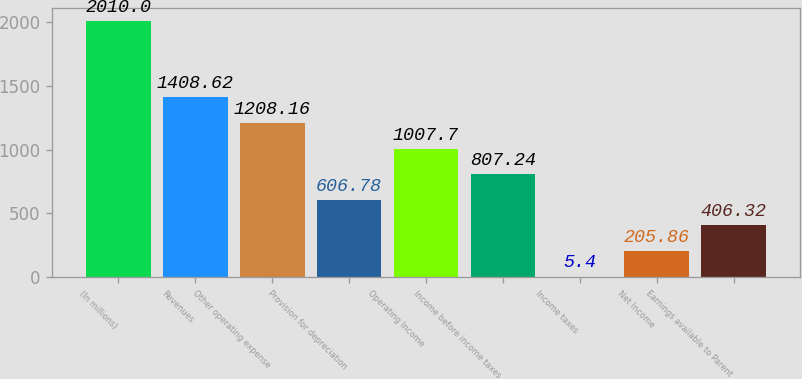Convert chart. <chart><loc_0><loc_0><loc_500><loc_500><bar_chart><fcel>(In millions)<fcel>Revenues<fcel>Other operating expense<fcel>Provision for depreciation<fcel>Operating Income<fcel>Income before income taxes<fcel>Income taxes<fcel>Net Income<fcel>Earnings available to Parent<nl><fcel>2010<fcel>1408.62<fcel>1208.16<fcel>606.78<fcel>1007.7<fcel>807.24<fcel>5.4<fcel>205.86<fcel>406.32<nl></chart> 